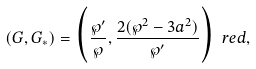<formula> <loc_0><loc_0><loc_500><loc_500>( G , G _ { \ast } ) = \Big { ( } \frac { { \wp } ^ { \prime } } { \wp } , \frac { 2 ( { \wp } ^ { 2 } - 3 a ^ { 2 } ) } { { \wp } ^ { \prime } } \Big { ) } \ r e d { , }</formula> 